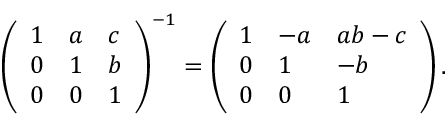<formula> <loc_0><loc_0><loc_500><loc_500>{ \left ( \begin{array} { l l l } { 1 } & { a } & { c } \\ { 0 } & { 1 } & { b } \\ { 0 } & { 0 } & { 1 } \end{array} \right ) } ^ { - 1 } = { \left ( \begin{array} { l l l } { 1 } & { - a } & { a b - c } \\ { 0 } & { 1 } & { - b } \\ { 0 } & { 0 } & { 1 } \end{array} \right ) } \, .</formula> 